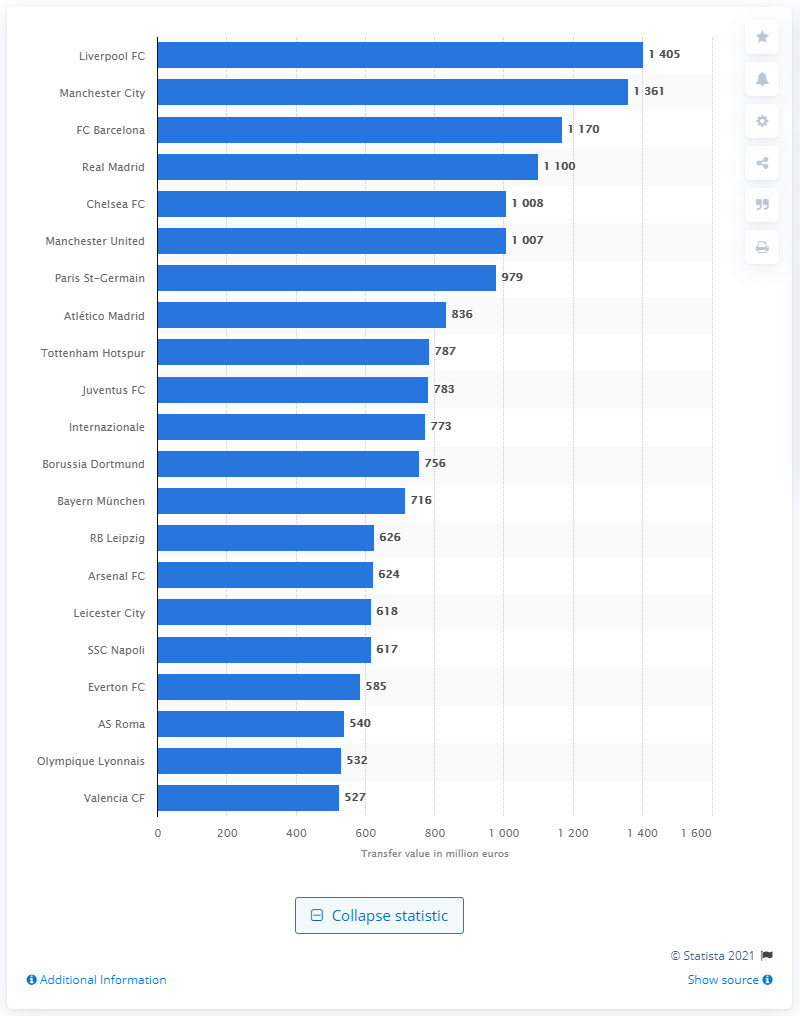Mention a couple of crucial points in this snapshot. The transfer value of Liverpool Football Club is 1405.. Liverpool Football Club is widely regarded as the most valuable soccer club in the world. 